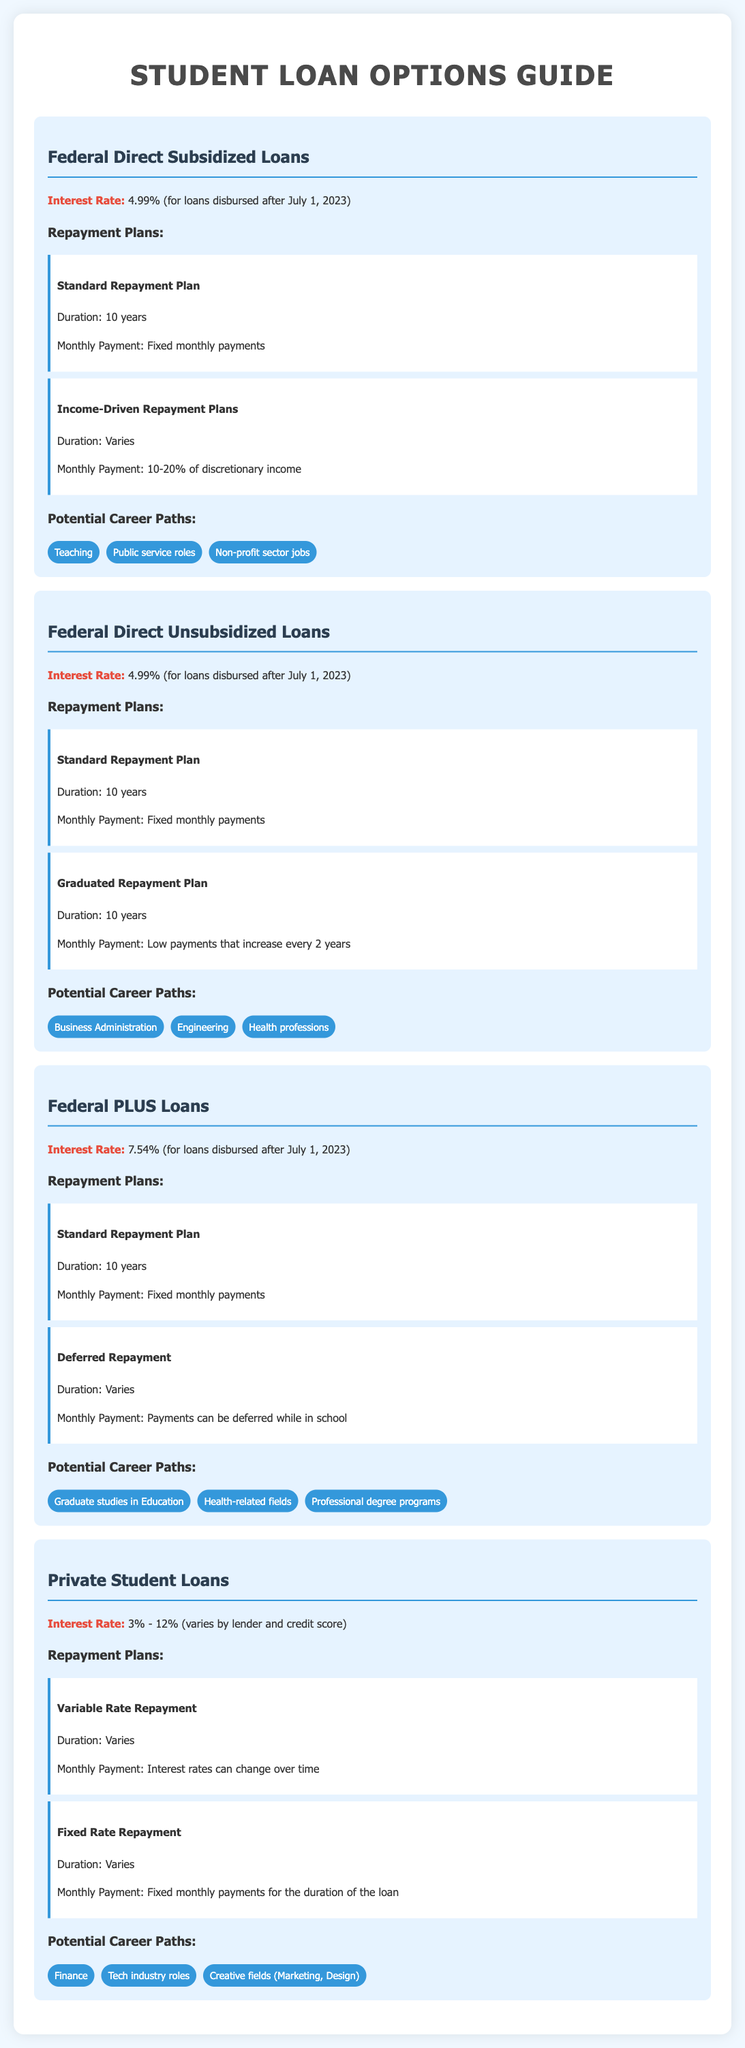What is the interest rate for Federal Direct Subsidized Loans? The interest rate for Federal Direct Subsidized Loans is specified in the document, which states it is 4.99% for loans disbursed after July 1, 2023.
Answer: 4.99% What repayment plan has a duration of 10 years for Federal PLUS Loans? The document mentions the Standard Repayment Plan with a duration of 10 years for Federal PLUS Loans.
Answer: Standard Repayment Plan What are the potential career paths linked to Private Student Loans? The document provides a list of potential career paths for Private Student Loans, specifically mentioning Finance, Tech industry roles, and Creative fields.
Answer: Finance, Tech industry roles, Creative fields What is the interest rate range for Private Student Loans? The document indicates that Private Student Loans have an interest rate that varies by lender and credit score, specifically ranging from 3% to 12%.
Answer: 3% - 12% Which repayment plan varies payments based on discretionary income for Federal Direct Subsidized Loans? The Income-Driven Repayment Plans, which are mentioned in the document as varying based on discretionary income, apply to Federal Direct Subsidized Loans.
Answer: Income-Driven Repayment Plans How long is the repayment duration for the Graduated Repayment Plan for Federal Direct Unsubsidized Loans? The document states that the Graduated Repayment Plan has a duration of 10 years for Federal Direct Unsubsidized Loans.
Answer: 10 years What type of loans are associated with teaching as a potential career path? The document links teaching as a potential career path with Federal Direct Subsidized Loans.
Answer: Federal Direct Subsidized Loans What types of repayment plans are available for Federal PLUS Loans? The document outlines two repayment plans for Federal PLUS Loans: Standard Repayment Plan and Deferred Repayment.
Answer: Standard Repayment Plan, Deferred Repayment What is a common feature of repayment plans for both Federal Direct Unsubsidized Loans and Federal Direct Subsidized Loans? Both types of loans offer a Standard Repayment Plan with a fixed monthly payment duration of 10 years, as per the document.
Answer: Standard Repayment Plan 